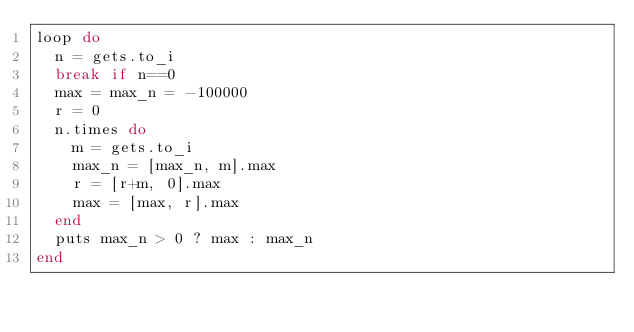Convert code to text. <code><loc_0><loc_0><loc_500><loc_500><_Ruby_>loop do
  n = gets.to_i
  break if n==0
  max = max_n = -100000
  r = 0
  n.times do
    m = gets.to_i
    max_n = [max_n, m].max
    r = [r+m, 0].max
    max = [max, r].max
  end
  puts max_n > 0 ? max : max_n
end</code> 